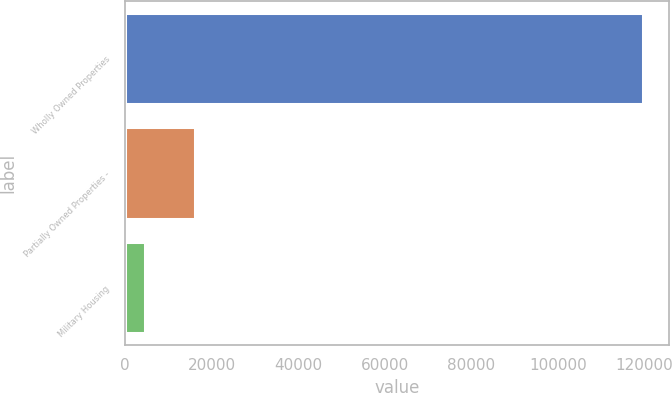Convert chart to OTSL. <chart><loc_0><loc_0><loc_500><loc_500><bar_chart><fcel>Wholly Owned Properties<fcel>Partially Owned Properties -<fcel>Military Housing<nl><fcel>119634<fcel>16227.6<fcel>4738<nl></chart> 